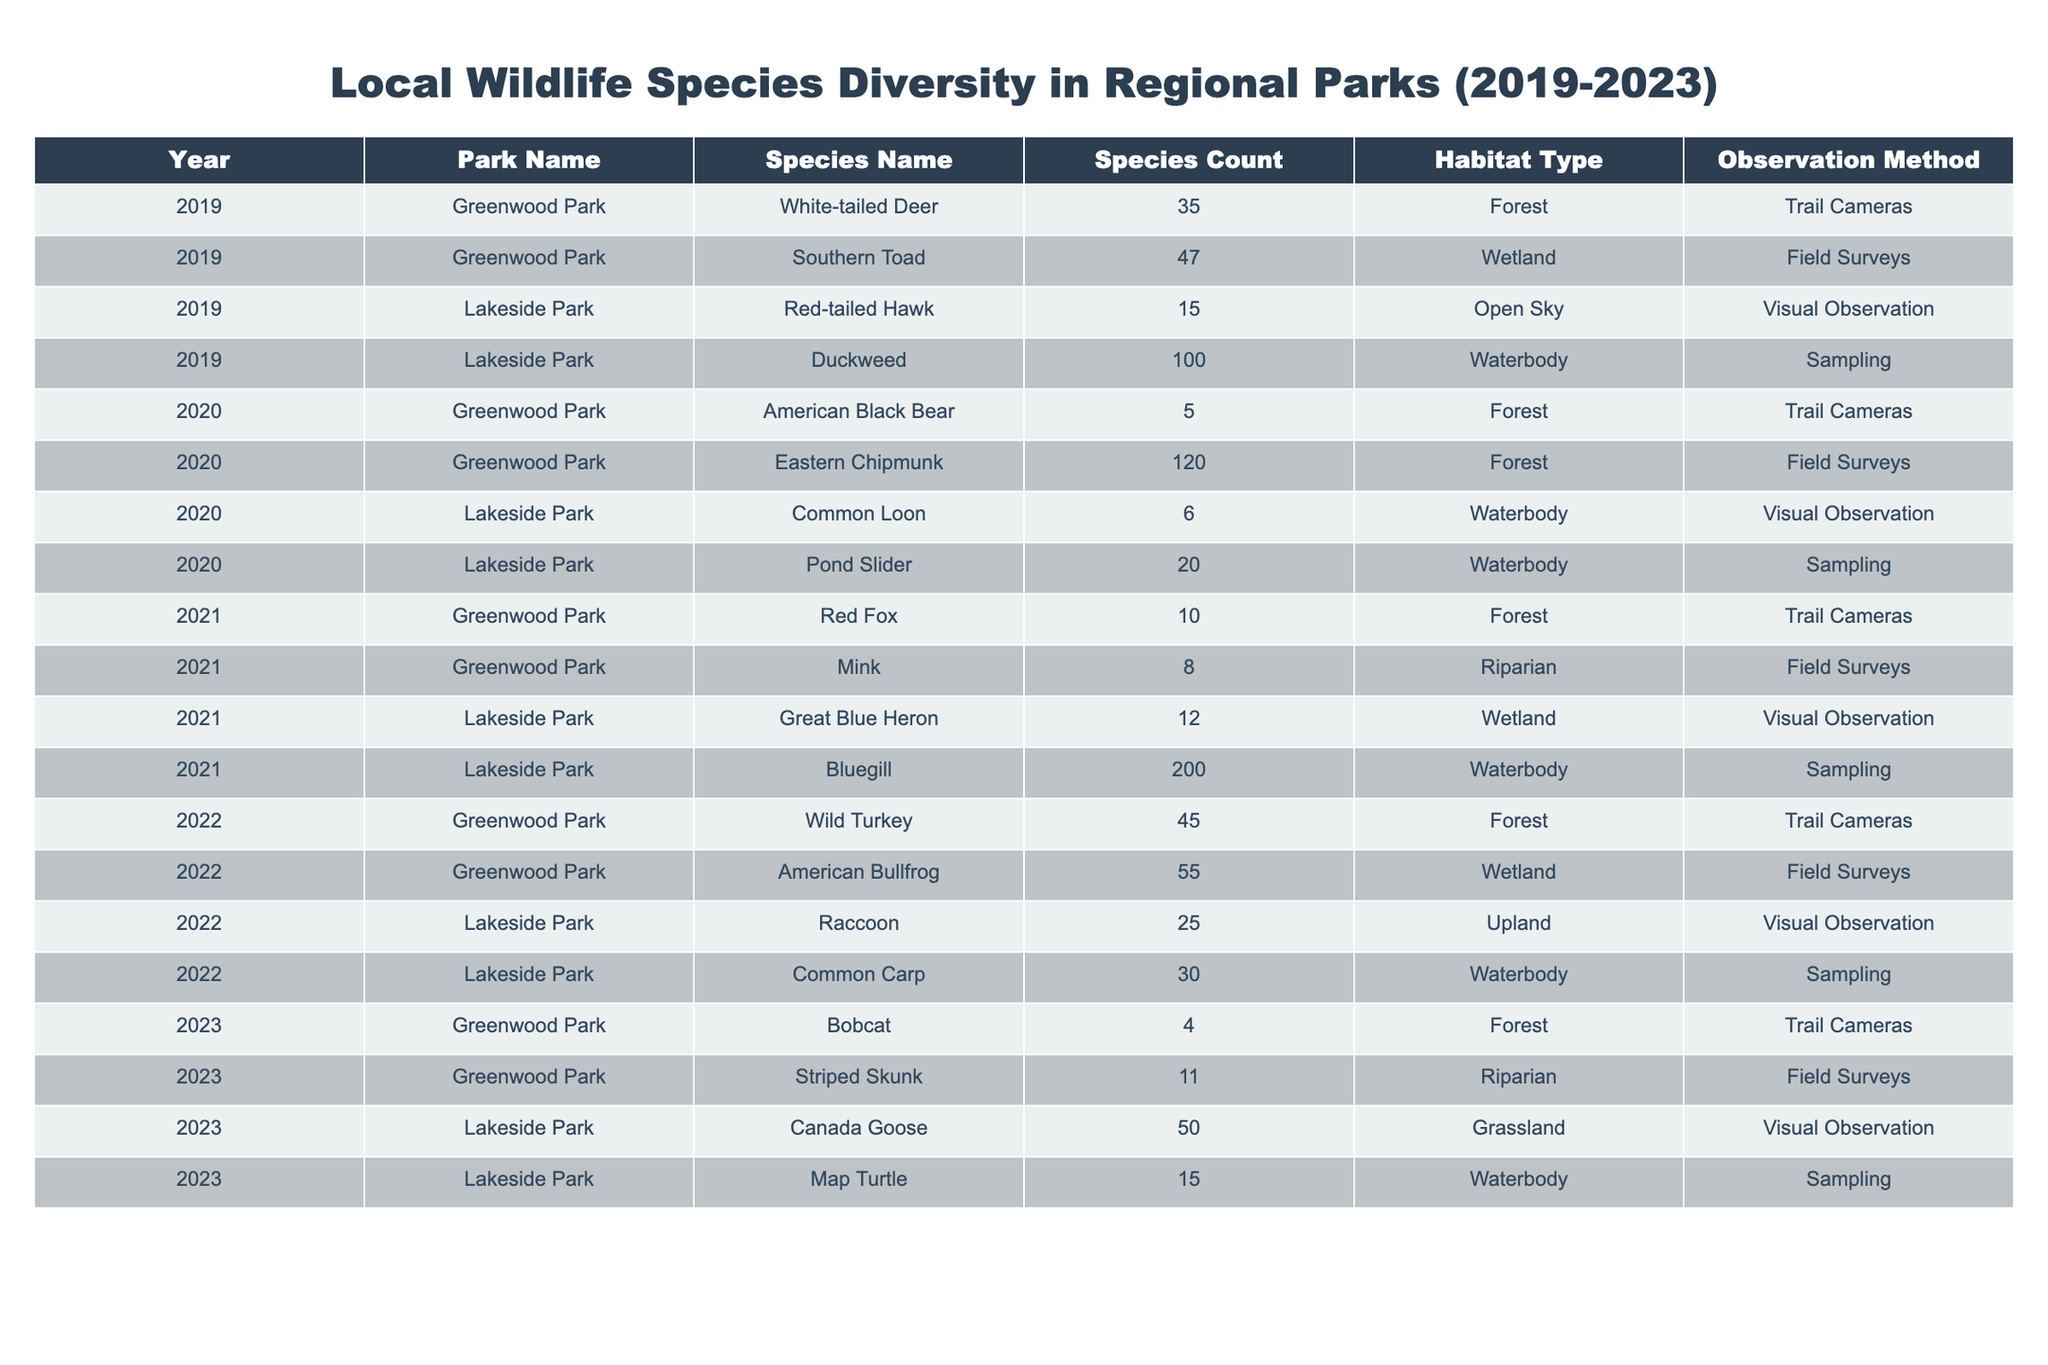What species had the highest count in Lakeside Park in 2021? In 2021, the Bluegill had a species count of 200 in Lakeside Park, which is higher than any other species count for that year in the same park.
Answer: Bluegill What was the total count of species in Greenwood Park over the years? Adding the species counts from Greenwood Park across all years: 35 (2019) + 47 (2019) + 5 (2020) + 120 (2020) + 10 (2021) + 8 (2021) + 45 (2022) + 55 (2022) + 4 (2023) + 11 (2023) = 392.
Answer: 392 Did Lakeside Park have more species counts in 2022 compared to 2020? In 2020, the species counts were 6 (Common Loon) + 20 (Pond Slider) = 26. In 2022, the counts were 25 (Raccoon) + 30 (Common Carp) = 55, which is greater.
Answer: Yes Which park had the least number of total species observed in 2023? In 2023, counting the species in each park, Greenwood Park had 15 (Striped Skunk) + 4 (Bobcat) = 19, and Lakeside Park had 50 (Canada Goose) + 15 (Map Turtle) = 65. Therefore, Greenwood Park had fewer total species.
Answer: Greenwood Park What is the average species count for Lakeside Park over the five years? The total species counts over the five years for Lakeside Park are: 15 (2019) + 100 (2019) + 6 (2020) + 20 (2020) + 12 (2021) + 200 (2021) + 25 (2022) + 30 (2022) + 50 (2023) + 15 (2023) = 408. There are 10 data points, so the average is 408/10 = 40.8.
Answer: 40.8 Was there any year when a species was not observed in Greenwood Park? Reviewing each year from 2019 to 2023, we see species were recorded in every year (White-tailed Deer, American Black Bear, Red Fox, etc.). Thus, there is no year with no observations.
Answer: No Which species was observed only in Lakeside Park during this period? The species that was only observed in Lakeside Park during the given period is Duckweed noted in 2019 as it does not appear in other years for other parks.
Answer: Duckweed What year saw the recorded presence of the American Bullfrog in Greenwood Park? The American Bullfrog was recorded in 2022 in Greenwood Park, which is the only year it appears in the data set.
Answer: 2022 